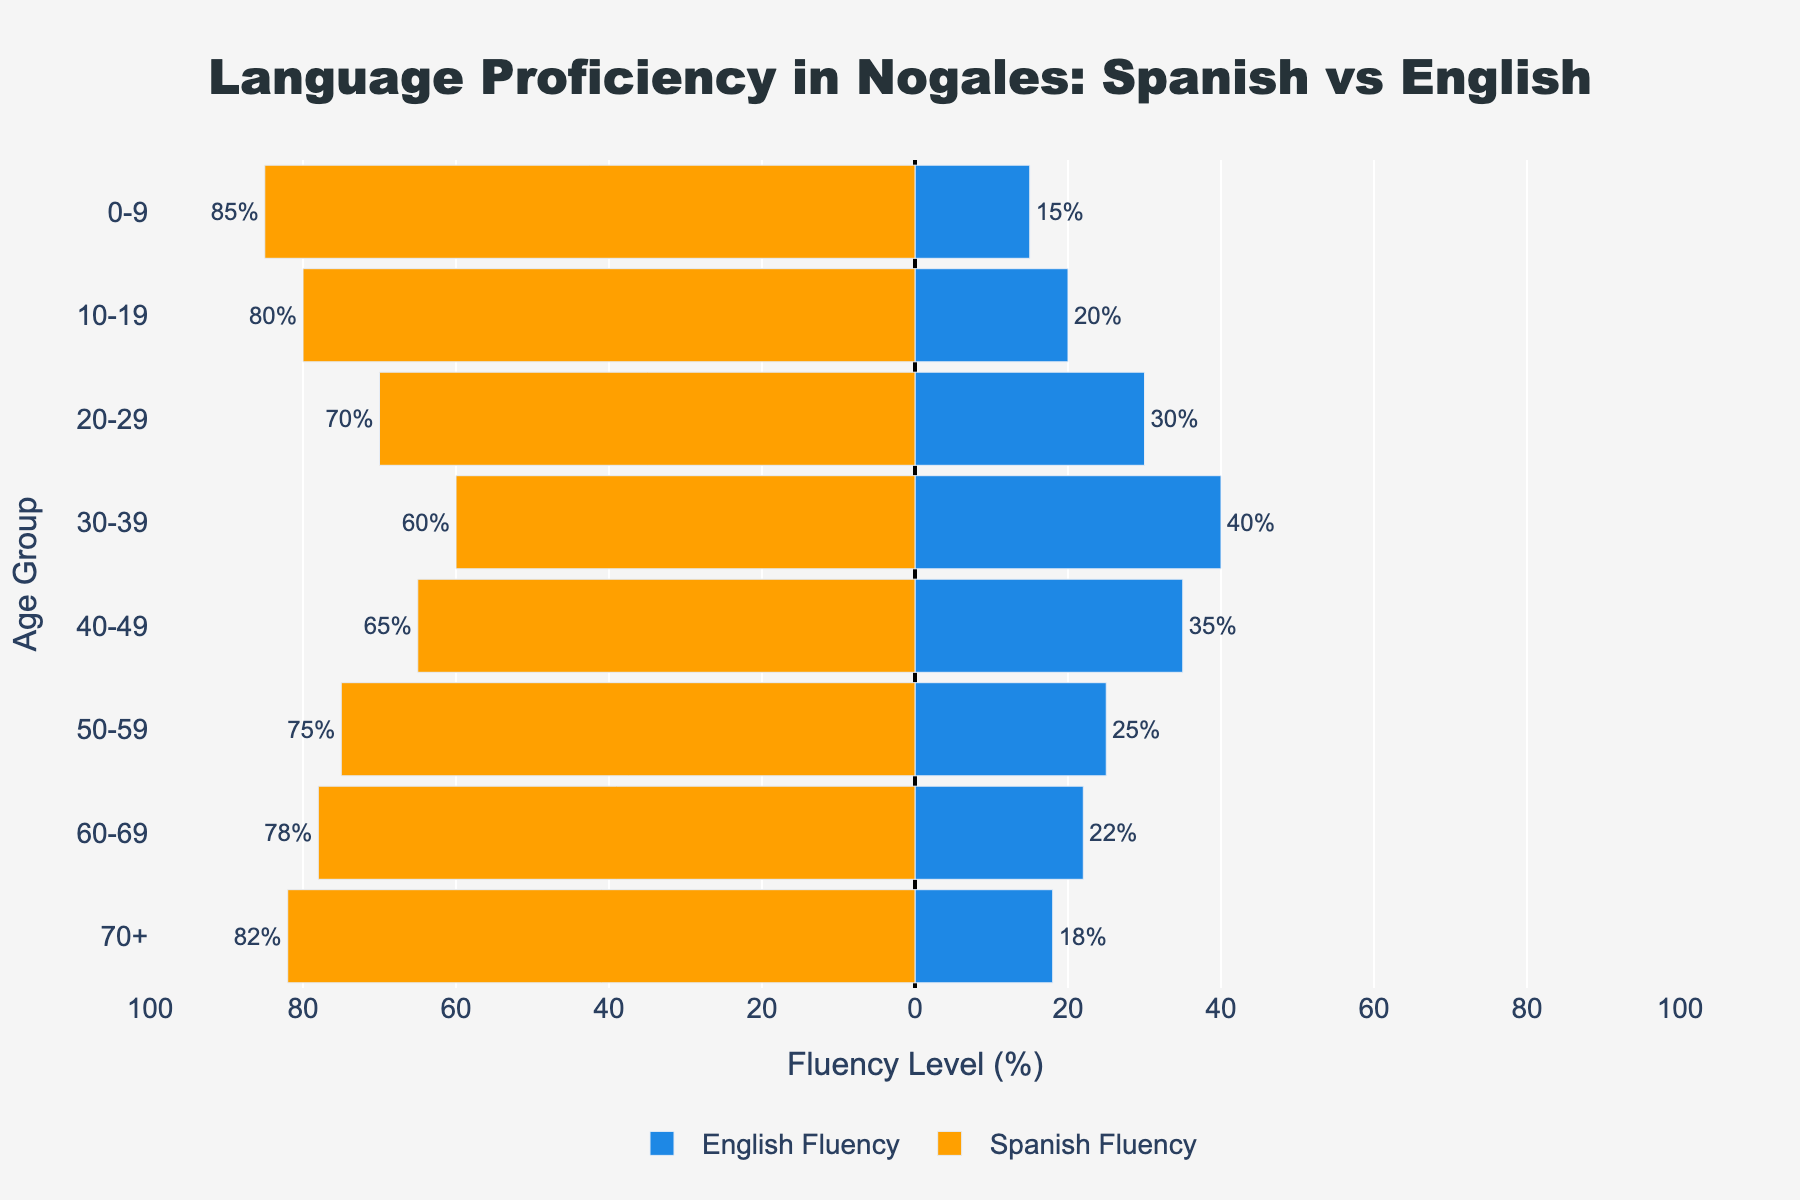What age group has the highest Spanish fluency? The Spanish fluency is represented by the length of the orange bars extending to the left. The longest orange bar corresponds to the age group 0-9 with 85%.
Answer: 0-9 How does the English fluency of the 30-39 age group compare to the 40-49 age group? Comparing the two blue bars for the age groups 30-39 and 40-49, the 30-39 age group has a fluency of 40%, while the 40-49 group has 35%.
Answer: 30-39 is higher Which age group shows the least fluency in English? Look for the shortest blue bar extending to the right. The shortest bar corresponds to the 0-9 age group with 15%.
Answer: 0-9 What is the total fluency (combined Spanish and English) for the 20-29 age group? For the 20-29 group: Spanish fluency is 70% and English fluency is 30%. Add these percentages: 70 + 30 = 100%.
Answer: 100% What is the difference in Spanish fluency between the 10-19 and 50-59 age groups? The Spanish fluency for 10-19 is 80%, and for 50-59 it is 75%. Subtract the two values: 80 - 75 = 5%.
Answer: 5% In which age groups is Spanish fluency higher than English fluency? Spanish fluency is higher in all age groups since all orange bars are longer than the blue bars for each corresponding age group.
Answer: All age groups How does English fluency for the 60-69 age group compare to that of the 70+ group? Compare the blue bars for the 60-69 and 70+ groups: 60-69 has 22% and 70+ has 18%.
Answer: 60-69 is higher How much higher is Spanish fluency in the 70+ age group compared to English fluency in the same group? The Spanish fluency for 70+ is 82% while English fluency is 18%. The difference is 82 - 18 = 64%.
Answer: 64% Which age group has the closest fluency levels between Spanish and English? The group with the smallest difference between the lengths of the orange and blue bars is 30-39. Spanish fluency is 60% and English fluency is 40%. The difference is 60 - 40 = 20%.
Answer: 30-39 